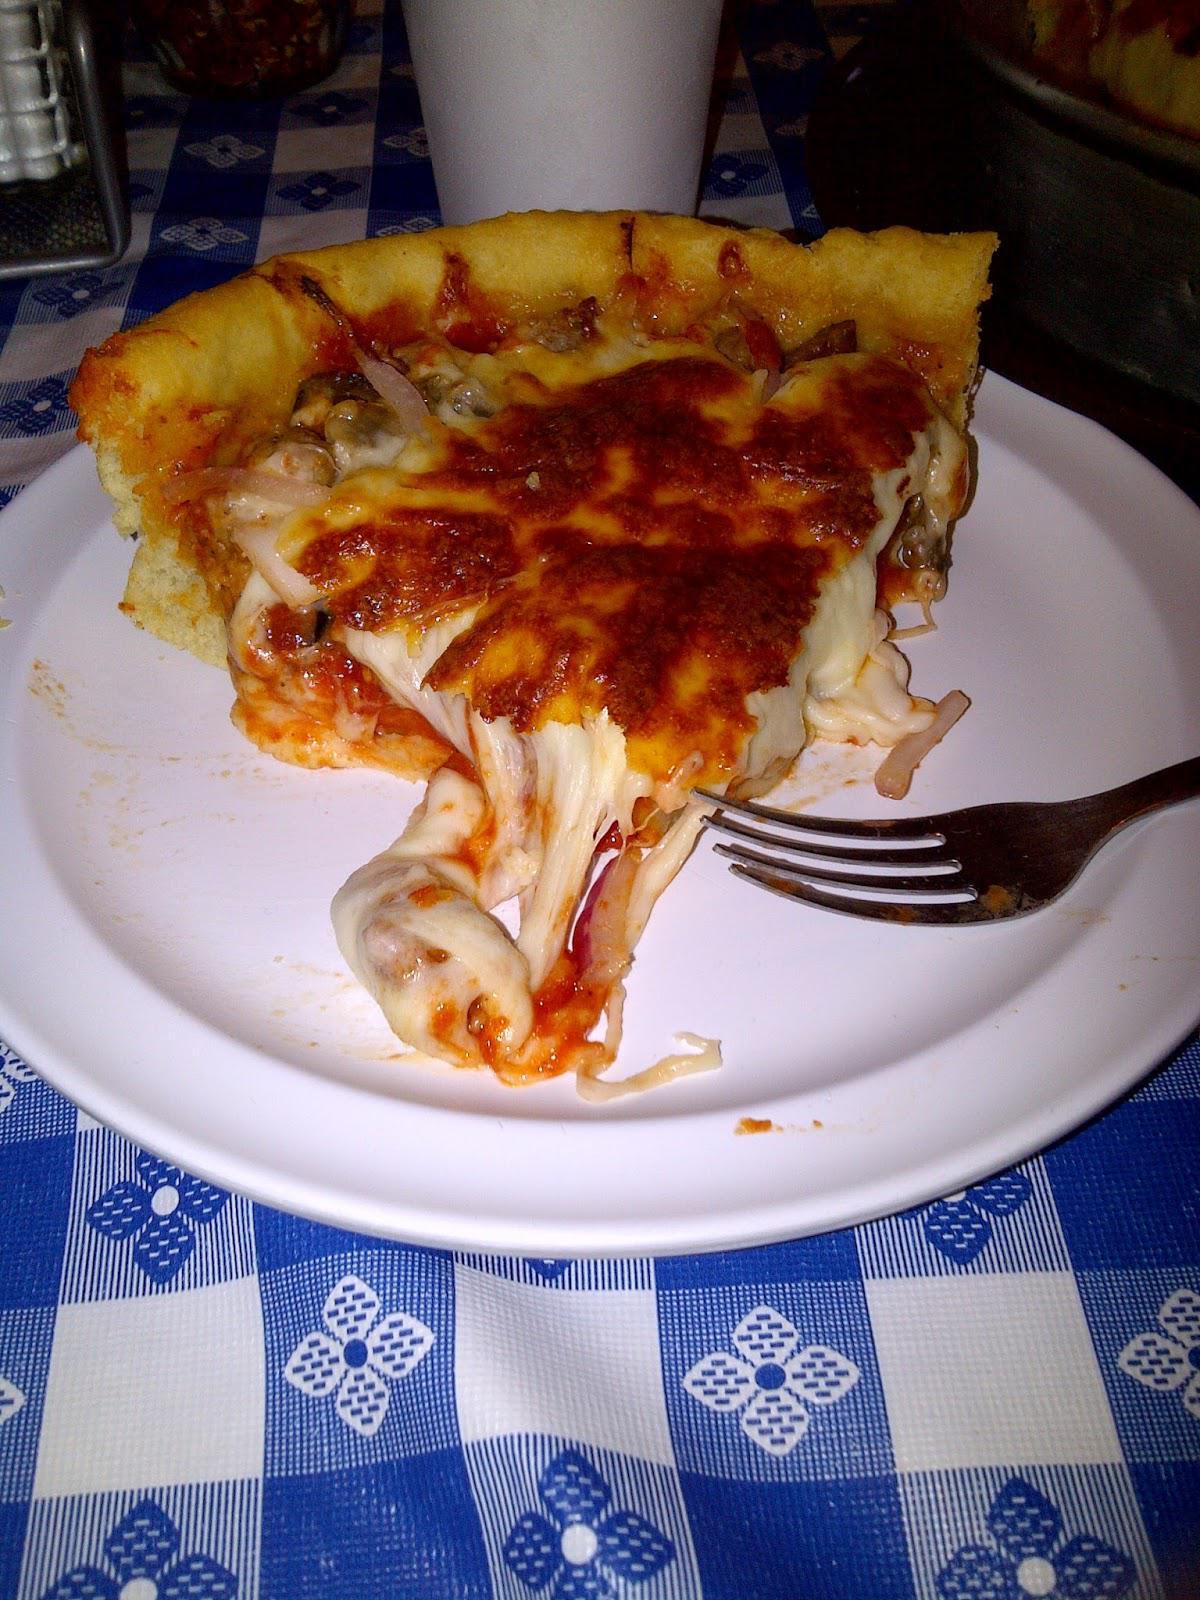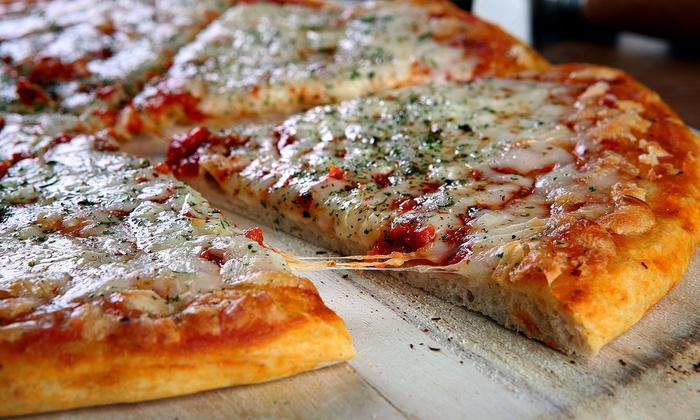The first image is the image on the left, the second image is the image on the right. Considering the images on both sides, is "The right image shows one round pizza with no slices missingon a round silver tray, and the left image shows at least part of a pizza smothered in white cheese on a round silver tray." valid? Answer yes or no. No. 